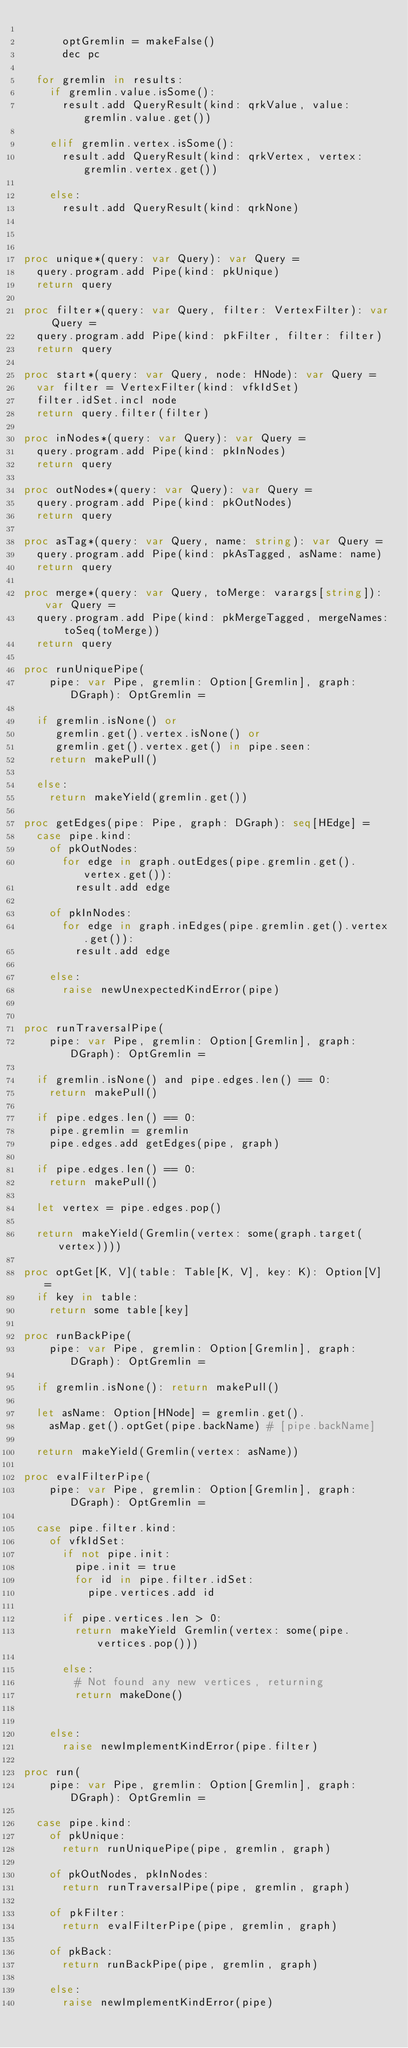Convert code to text. <code><loc_0><loc_0><loc_500><loc_500><_Nim_>
      optGremlin = makeFalse()
      dec pc

  for gremlin in results:
    if gremlin.value.isSome():
      result.add QueryResult(kind: qrkValue, value: gremlin.value.get())

    elif gremlin.vertex.isSome():
      result.add QueryResult(kind: qrkVertex, vertex: gremlin.vertex.get())

    else:
      result.add QueryResult(kind: qrkNone)



proc unique*(query: var Query): var Query =
  query.program.add Pipe(kind: pkUnique)
  return query

proc filter*(query: var Query, filter: VertexFilter): var Query =
  query.program.add Pipe(kind: pkFilter, filter: filter)
  return query

proc start*(query: var Query, node: HNode): var Query =
  var filter = VertexFilter(kind: vfkIdSet)
  filter.idSet.incl node
  return query.filter(filter)

proc inNodes*(query: var Query): var Query =
  query.program.add Pipe(kind: pkInNodes)
  return query

proc outNodes*(query: var Query): var Query =
  query.program.add Pipe(kind: pkOutNodes)
  return query

proc asTag*(query: var Query, name: string): var Query =
  query.program.add Pipe(kind: pkAsTagged, asName: name)
  return query

proc merge*(query: var Query, toMerge: varargs[string]): var Query =
  query.program.add Pipe(kind: pkMergeTagged, mergeNames: toSeq(toMerge))
  return query

proc runUniquePipe(
    pipe: var Pipe, gremlin: Option[Gremlin], graph: DGraph): OptGremlin =

  if gremlin.isNone() or
     gremlin.get().vertex.isNone() or
     gremlin.get().vertex.get() in pipe.seen:
    return makePull()

  else:
    return makeYield(gremlin.get())

proc getEdges(pipe: Pipe, graph: DGraph): seq[HEdge] =
  case pipe.kind:
    of pkOutNodes:
      for edge in graph.outEdges(pipe.gremlin.get().vertex.get()):
        result.add edge

    of pkInNodes:
      for edge in graph.inEdges(pipe.gremlin.get().vertex.get()):
        result.add edge

    else:
      raise newUnexpectedKindError(pipe)


proc runTraversalPipe(
    pipe: var Pipe, gremlin: Option[Gremlin], graph: DGraph): OptGremlin =

  if gremlin.isNone() and pipe.edges.len() == 0:
    return makePull()

  if pipe.edges.len() == 0:
    pipe.gremlin = gremlin
    pipe.edges.add getEdges(pipe, graph)

  if pipe.edges.len() == 0:
    return makePull()

  let vertex = pipe.edges.pop()

  return makeYield(Gremlin(vertex: some(graph.target(vertex))))

proc optGet[K, V](table: Table[K, V], key: K): Option[V] =
  if key in table:
    return some table[key]

proc runBackPipe(
    pipe: var Pipe, gremlin: Option[Gremlin], graph: DGraph): OptGremlin =

  if gremlin.isNone(): return makePull()

  let asName: Option[HNode] = gremlin.get().
    asMap.get().optGet(pipe.backName) # [pipe.backName]

  return makeYield(Gremlin(vertex: asName))

proc evalFilterPipe(
    pipe: var Pipe, gremlin: Option[Gremlin], graph: DGraph): OptGremlin =

  case pipe.filter.kind:
    of vfkIdSet:
      if not pipe.init:
        pipe.init = true
        for id in pipe.filter.idSet:
          pipe.vertices.add id

      if pipe.vertices.len > 0:
        return makeYield Gremlin(vertex: some(pipe.vertices.pop()))

      else:
        # Not found any new vertices, returning
        return makeDone()


    else:
      raise newImplementKindError(pipe.filter)

proc run(
    pipe: var Pipe, gremlin: Option[Gremlin], graph: DGraph): OptGremlin =

  case pipe.kind:
    of pkUnique:
      return runUniquePipe(pipe, gremlin, graph)

    of pkOutNodes, pkInNodes:
      return runTraversalPipe(pipe, gremlin, graph)

    of pkFilter:
      return evalFilterPipe(pipe, gremlin, graph)

    of pkBack:
      return runBackPipe(pipe, gremlin, graph)

    else:
      raise newImplementKindError(pipe)
</code> 